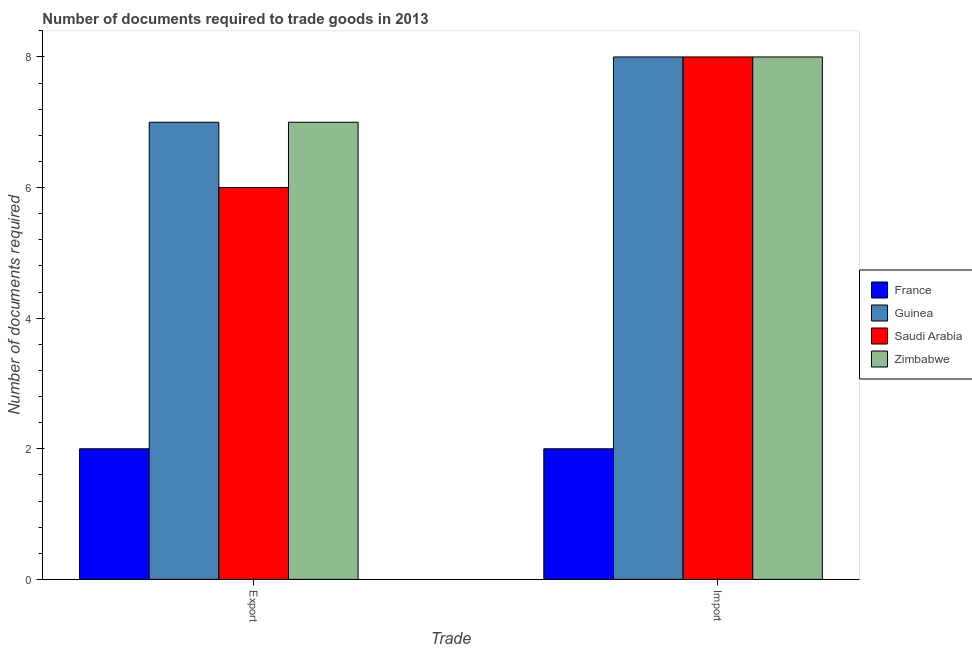How many different coloured bars are there?
Keep it short and to the point. 4. Are the number of bars per tick equal to the number of legend labels?
Ensure brevity in your answer.  Yes. Are the number of bars on each tick of the X-axis equal?
Provide a succinct answer. Yes. What is the label of the 1st group of bars from the left?
Make the answer very short. Export. What is the number of documents required to export goods in Guinea?
Keep it short and to the point. 7. Across all countries, what is the maximum number of documents required to import goods?
Keep it short and to the point. 8. Across all countries, what is the minimum number of documents required to import goods?
Offer a very short reply. 2. In which country was the number of documents required to export goods maximum?
Provide a short and direct response. Guinea. In which country was the number of documents required to import goods minimum?
Offer a terse response. France. What is the total number of documents required to export goods in the graph?
Your answer should be very brief. 22. What is the difference between the number of documents required to export goods in France and that in Saudi Arabia?
Ensure brevity in your answer.  -4. What is the difference between the number of documents required to export goods in France and the number of documents required to import goods in Guinea?
Offer a very short reply. -6. What is the average number of documents required to import goods per country?
Make the answer very short. 6.5. In how many countries, is the number of documents required to export goods greater than 5.6 ?
Ensure brevity in your answer.  3. What is the ratio of the number of documents required to import goods in Guinea to that in France?
Your response must be concise. 4. In how many countries, is the number of documents required to export goods greater than the average number of documents required to export goods taken over all countries?
Give a very brief answer. 3. What does the 3rd bar from the right in Export represents?
Give a very brief answer. Guinea. How many bars are there?
Offer a terse response. 8. Are all the bars in the graph horizontal?
Give a very brief answer. No. How many countries are there in the graph?
Ensure brevity in your answer.  4. What is the difference between two consecutive major ticks on the Y-axis?
Keep it short and to the point. 2. Does the graph contain any zero values?
Give a very brief answer. No. Does the graph contain grids?
Offer a very short reply. No. How many legend labels are there?
Keep it short and to the point. 4. How are the legend labels stacked?
Offer a terse response. Vertical. What is the title of the graph?
Your answer should be compact. Number of documents required to trade goods in 2013. Does "High income" appear as one of the legend labels in the graph?
Make the answer very short. No. What is the label or title of the X-axis?
Provide a short and direct response. Trade. What is the label or title of the Y-axis?
Give a very brief answer. Number of documents required. What is the Number of documents required of Guinea in Export?
Provide a succinct answer. 7. What is the Number of documents required in Saudi Arabia in Export?
Provide a short and direct response. 6. What is the Number of documents required of France in Import?
Make the answer very short. 2. What is the Number of documents required of Guinea in Import?
Make the answer very short. 8. What is the Number of documents required of Zimbabwe in Import?
Offer a very short reply. 8. Across all Trade, what is the maximum Number of documents required in Guinea?
Provide a short and direct response. 8. Across all Trade, what is the minimum Number of documents required of France?
Your answer should be very brief. 2. Across all Trade, what is the minimum Number of documents required in Zimbabwe?
Give a very brief answer. 7. What is the total Number of documents required of France in the graph?
Provide a succinct answer. 4. What is the total Number of documents required of Guinea in the graph?
Offer a terse response. 15. What is the total Number of documents required in Zimbabwe in the graph?
Your answer should be very brief. 15. What is the difference between the Number of documents required of France in Export and that in Import?
Your answer should be compact. 0. What is the difference between the Number of documents required of Saudi Arabia in Export and that in Import?
Your response must be concise. -2. What is the difference between the Number of documents required of Guinea in Export and the Number of documents required of Saudi Arabia in Import?
Ensure brevity in your answer.  -1. What is the difference between the Number of documents required in Guinea in Export and the Number of documents required in Zimbabwe in Import?
Keep it short and to the point. -1. What is the average Number of documents required of Saudi Arabia per Trade?
Your answer should be very brief. 7. What is the average Number of documents required in Zimbabwe per Trade?
Offer a terse response. 7.5. What is the difference between the Number of documents required in France and Number of documents required in Guinea in Export?
Make the answer very short. -5. What is the difference between the Number of documents required in France and Number of documents required in Saudi Arabia in Export?
Your response must be concise. -4. What is the difference between the Number of documents required of France and Number of documents required of Zimbabwe in Export?
Provide a succinct answer. -5. What is the difference between the Number of documents required in Saudi Arabia and Number of documents required in Zimbabwe in Export?
Offer a terse response. -1. What is the ratio of the Number of documents required in France in Export to that in Import?
Make the answer very short. 1. What is the ratio of the Number of documents required in Guinea in Export to that in Import?
Your response must be concise. 0.88. What is the ratio of the Number of documents required in Saudi Arabia in Export to that in Import?
Your answer should be compact. 0.75. What is the ratio of the Number of documents required in Zimbabwe in Export to that in Import?
Your answer should be compact. 0.88. What is the difference between the highest and the second highest Number of documents required in France?
Your answer should be very brief. 0. What is the difference between the highest and the second highest Number of documents required of Saudi Arabia?
Provide a succinct answer. 2. What is the difference between the highest and the second highest Number of documents required of Zimbabwe?
Your answer should be very brief. 1. What is the difference between the highest and the lowest Number of documents required in France?
Ensure brevity in your answer.  0. What is the difference between the highest and the lowest Number of documents required of Guinea?
Provide a short and direct response. 1. What is the difference between the highest and the lowest Number of documents required of Saudi Arabia?
Offer a terse response. 2. What is the difference between the highest and the lowest Number of documents required of Zimbabwe?
Provide a short and direct response. 1. 